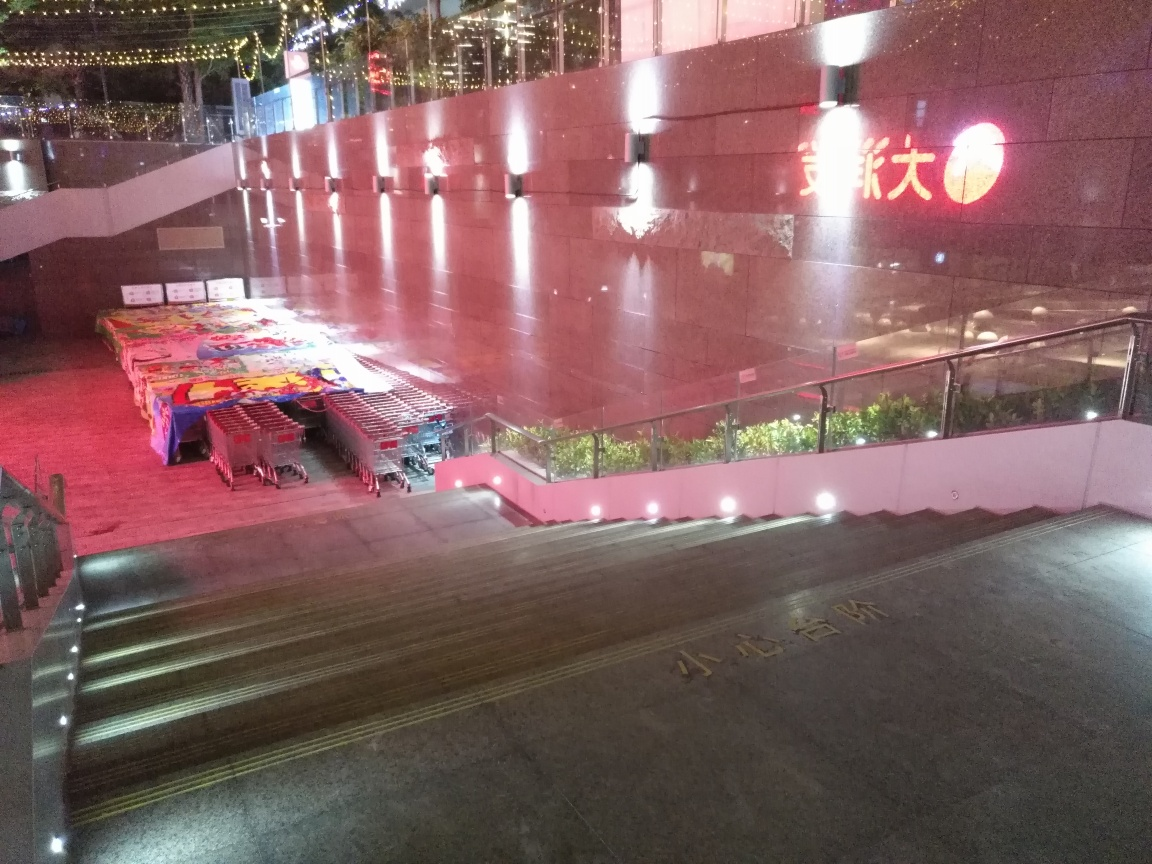Are there any indications of location or cultural significance in this image? The characters on the building suggest a location where Chinese is used, possibly indicating an East Asian context. The setting and arrangement of objects might be part of a market or an outdoor venue, which can have cultural significance as a place of commerce and community gathering. 